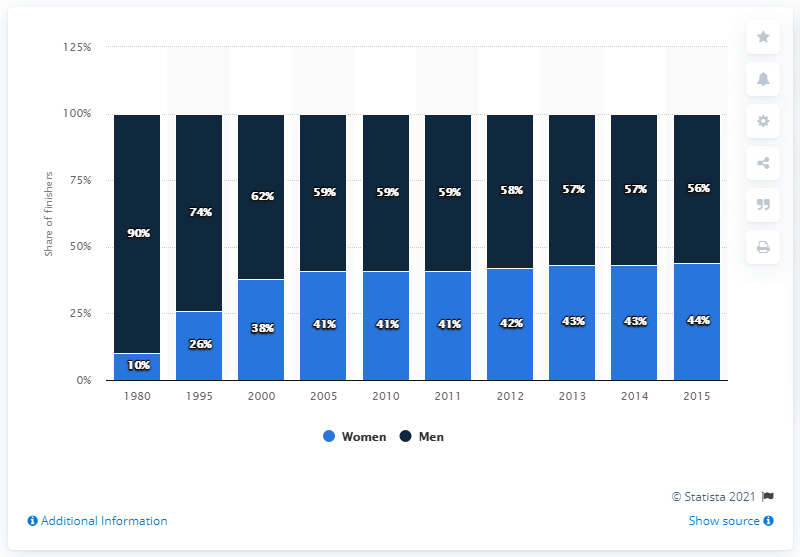Point out several critical features in this image. In 2013, approximately 57% of men who participated in the marathon in the United States completed the race. The difference between the men and women finishing the marathon was maximum in 1980. 